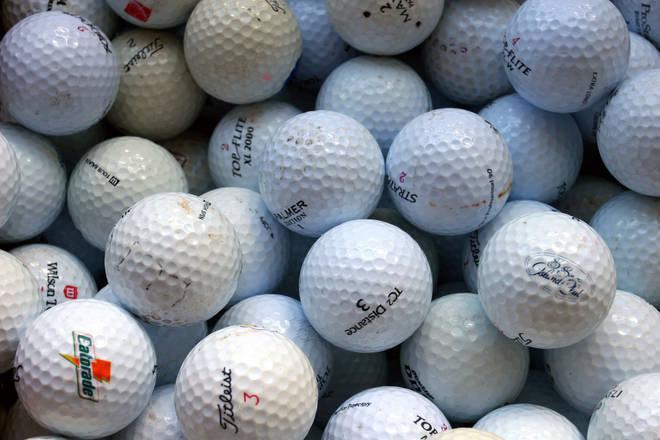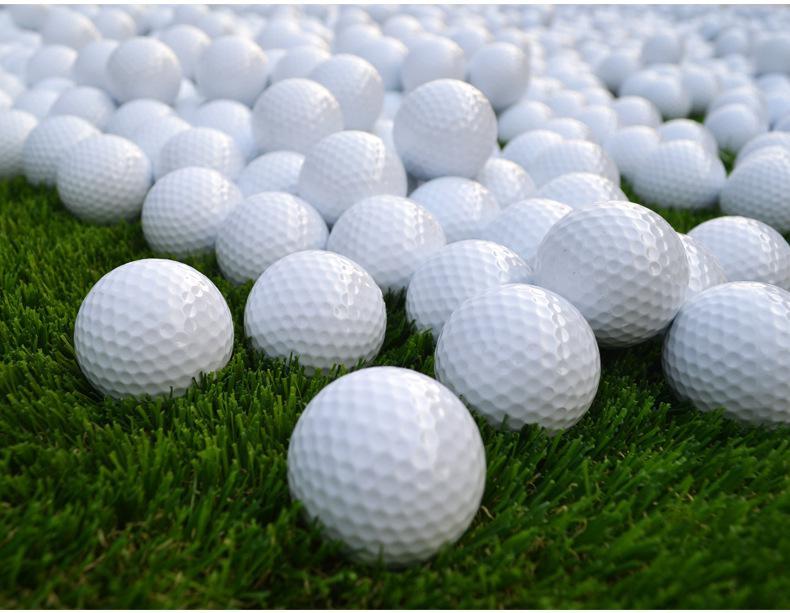The first image is the image on the left, the second image is the image on the right. Considering the images on both sides, is "All golf balls shown are plain and unmarked." valid? Answer yes or no. No. 